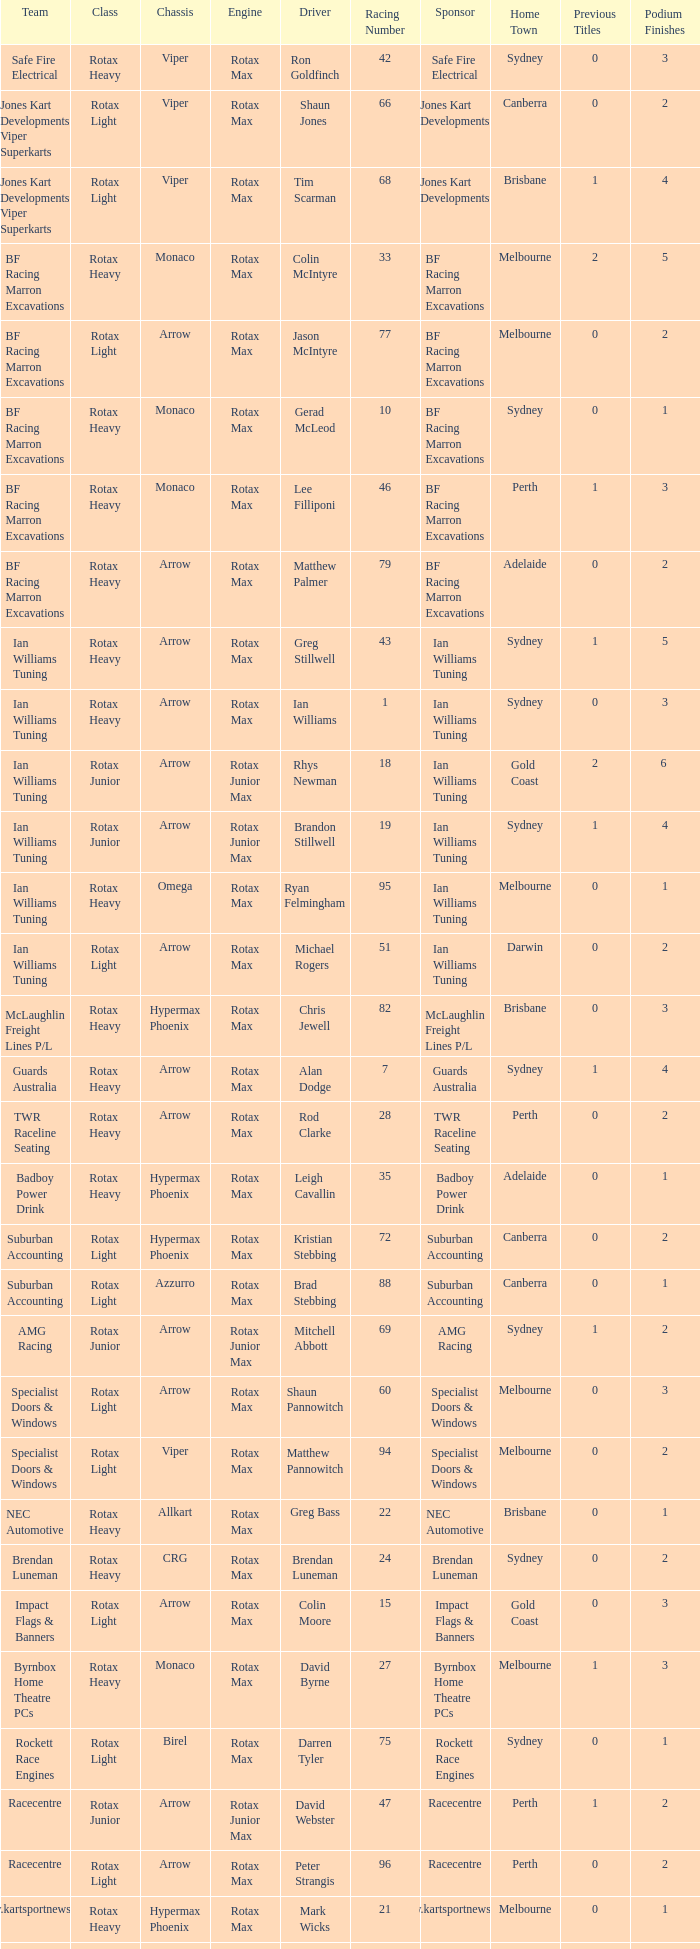What is the name of the team whose class is Rotax Light? Jones Kart Developments Viper Superkarts, Jones Kart Developments Viper Superkarts, BF Racing Marron Excavations, Ian Williams Tuning, Suburban Accounting, Suburban Accounting, Specialist Doors & Windows, Specialist Doors & Windows, Impact Flags & Banners, Rockett Race Engines, Racecentre, Doug Savage. 